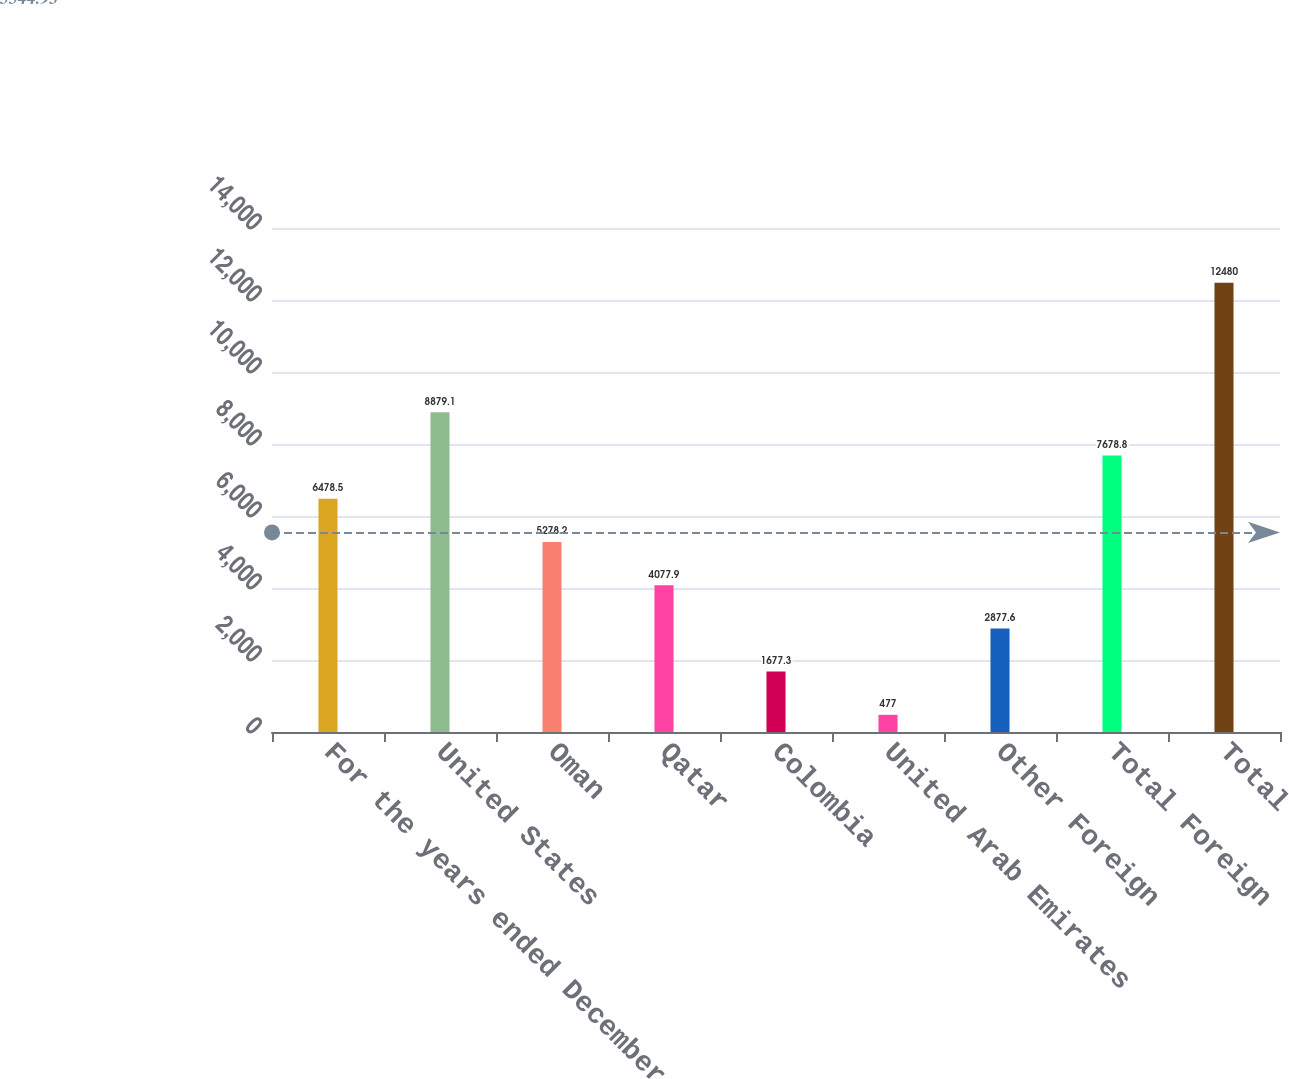Convert chart. <chart><loc_0><loc_0><loc_500><loc_500><bar_chart><fcel>For the years ended December<fcel>United States<fcel>Oman<fcel>Qatar<fcel>Colombia<fcel>United Arab Emirates<fcel>Other Foreign<fcel>Total Foreign<fcel>Total<nl><fcel>6478.5<fcel>8879.1<fcel>5278.2<fcel>4077.9<fcel>1677.3<fcel>477<fcel>2877.6<fcel>7678.8<fcel>12480<nl></chart> 